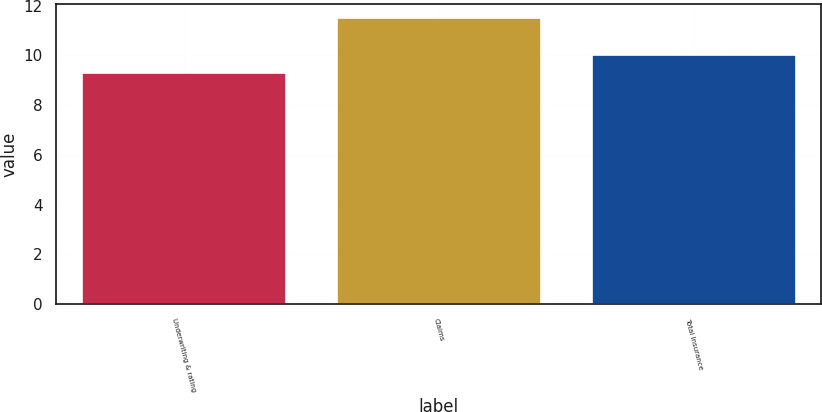<chart> <loc_0><loc_0><loc_500><loc_500><bar_chart><fcel>Underwriting & rating<fcel>Claims<fcel>Total Insurance<nl><fcel>9.3<fcel>11.5<fcel>10<nl></chart> 